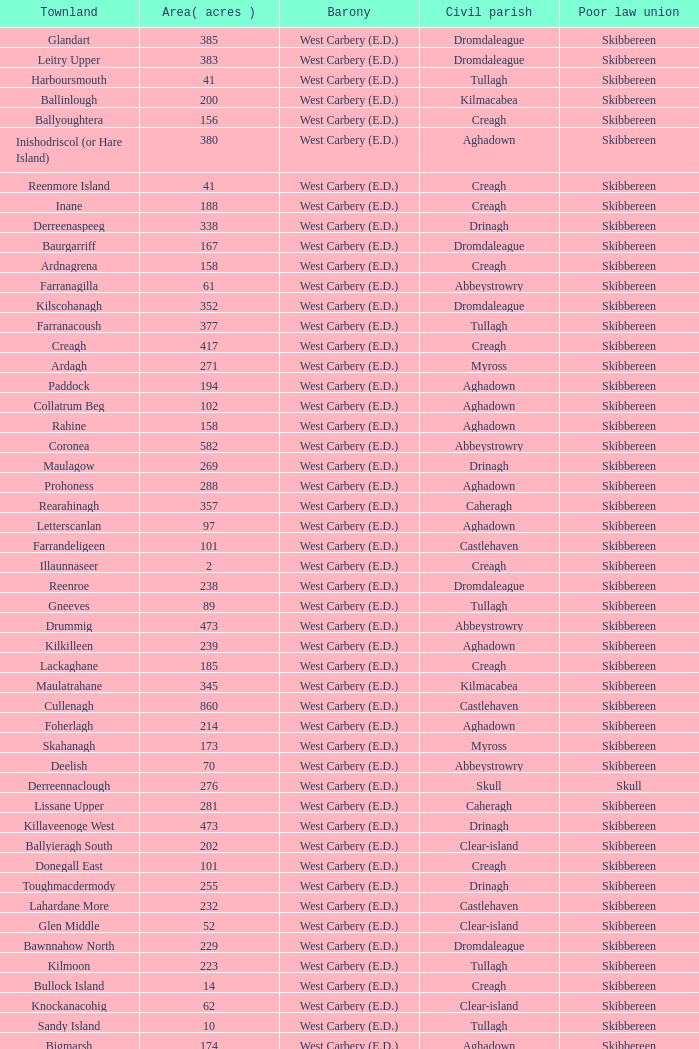What are the Baronies when the area (in acres) is 276? West Carbery (E.D.). 